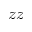<formula> <loc_0><loc_0><loc_500><loc_500>z z</formula> 